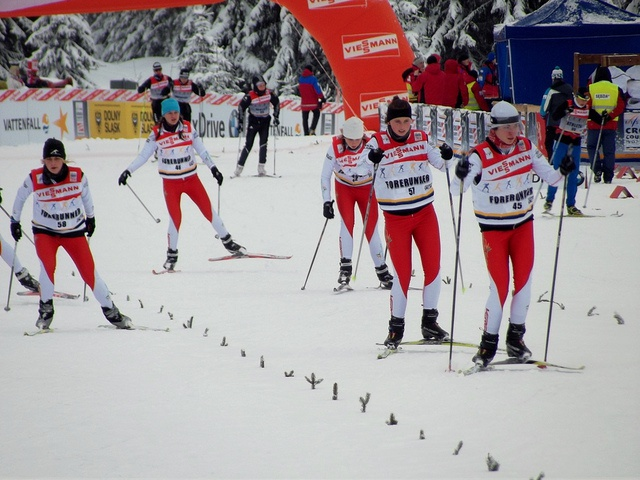Describe the objects in this image and their specific colors. I can see people in gray, darkgray, brown, and black tones, people in gray, brown, black, and darkgray tones, people in gray, darkgray, brown, and black tones, people in gray, brown, darkgray, and black tones, and people in gray, brown, darkgray, and black tones in this image. 